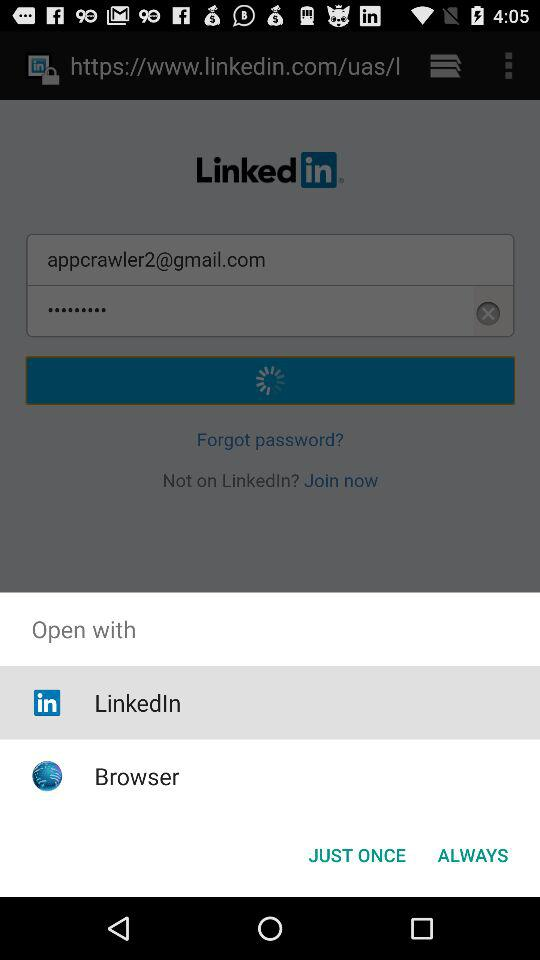What is the email address? The email address is appcrawler2@gmail.com. 